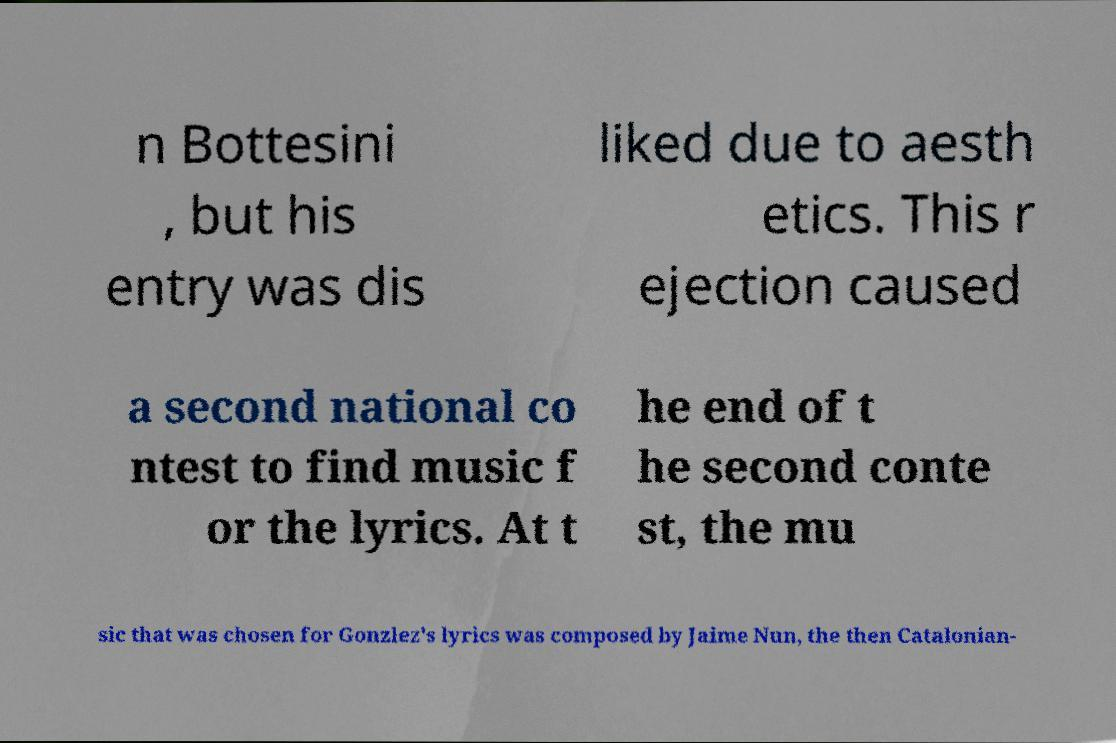Can you accurately transcribe the text from the provided image for me? n Bottesini , but his entry was dis liked due to aesth etics. This r ejection caused a second national co ntest to find music f or the lyrics. At t he end of t he second conte st, the mu sic that was chosen for Gonzlez's lyrics was composed by Jaime Nun, the then Catalonian- 